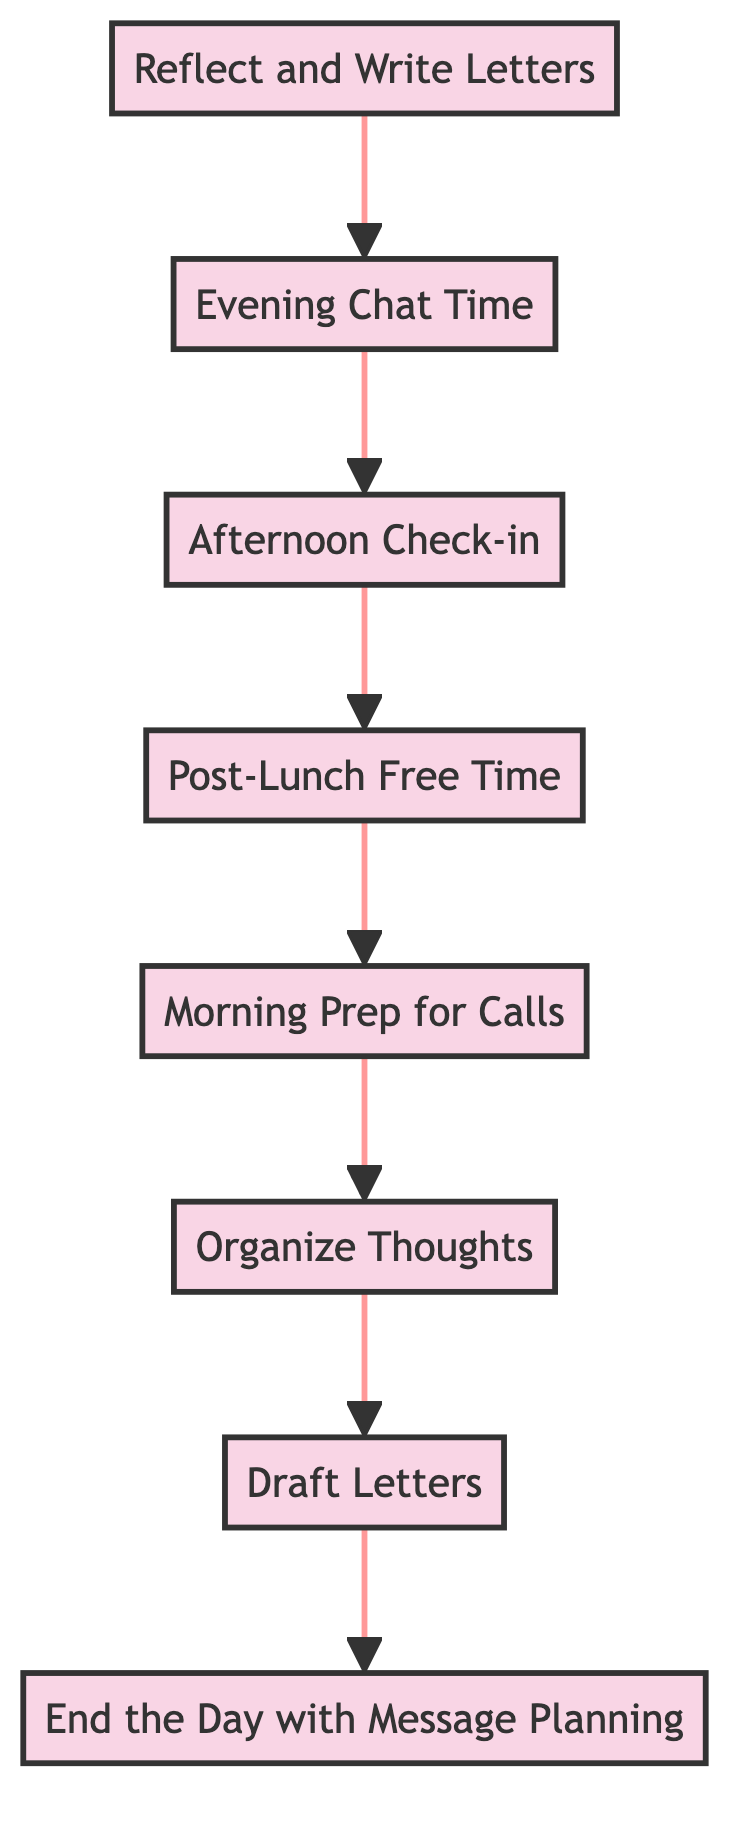What is the first step in the communication schedule? According to the flowchart, the first step in the communication schedule is "Reflect and Write Letters", as it is positioned at the bottom of the diagram.
Answer: Reflect and Write Letters How many nodes are present in the diagram? The diagram contains eight distinct nodes, each representing a different step in the communication schedule.
Answer: 8 Which step follows "Post-Lunch Free Time"? The step that directly follows "Post-Lunch Free Time" in the flowchart is "Morning Prep for Calls", as the flow moves upwards in order of tasks.
Answer: Morning Prep for Calls What is the final step in the communication schedule? The final step at the top of the flowchart is "End the Day with Message Planning", indicating it is the last task to be completed.
Answer: End the Day with Message Planning What two steps are connected directly? The steps "Draft Letters" and "Organize Thoughts" are directly connected, with "Draft Letters" flowing upward from "Organize Thoughts".
Answer: Draft Letters and Organize Thoughts What is a reason for the step "Morning Prep for Calls"? The purpose of the "Morning Prep for Calls" step is to prepare for upcoming conversations, ensuring that relevant topics are noted ahead of time.
Answer: Preparing for conversations Which step involves informal chats? The step that involves informal chats is "Evening Chat Time", as indicated in the flowchart where it specifically mentions chat time via video or phone calls.
Answer: Evening Chat Time What is the starting point for drafting letters? The starting point for drafting letters occurs during "Reflect and Write Letters", where the individual uses quiet time to reflect and then drafts heartfelt messages.
Answer: Reflect and Write Letters What operation occurs after "Organize Thoughts"? After "Organize Thoughts", the operation that occurs is "Draft Letters", indicating the transition from arranging thoughts to writing them down.
Answer: Draft Letters 